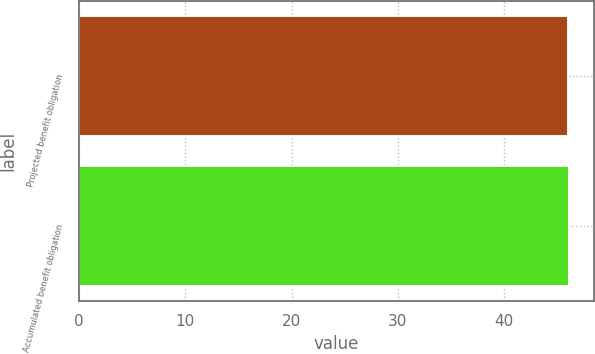Convert chart to OTSL. <chart><loc_0><loc_0><loc_500><loc_500><bar_chart><fcel>Projected benefit obligation<fcel>Accumulated benefit obligation<nl><fcel>46<fcel>46.1<nl></chart> 